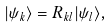<formula> <loc_0><loc_0><loc_500><loc_500>| \psi _ { k } \rangle = R _ { k l } | \psi _ { l } \rangle ,</formula> 